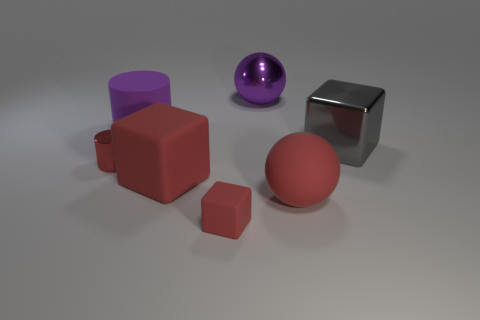Are there an equal number of metallic blocks that are behind the purple sphere and large metal blocks behind the big purple cylinder?
Your answer should be very brief. Yes. Are there any other things that have the same size as the rubber sphere?
Ensure brevity in your answer.  Yes. There is a big red thing that is the same shape as the small red matte object; what material is it?
Ensure brevity in your answer.  Rubber. Is there a big gray shiny thing left of the big matte thing to the right of the sphere that is behind the gray cube?
Your answer should be very brief. No. Does the large metallic thing that is behind the large gray metal thing have the same shape as the large matte thing that is behind the small cylinder?
Give a very brief answer. No. Is the number of red metallic cylinders left of the large rubber cylinder greater than the number of small red rubber objects?
Give a very brief answer. No. What number of things are big cubes or tiny blue spheres?
Your answer should be very brief. 2. What color is the rubber cylinder?
Make the answer very short. Purple. How many other things are there of the same color as the metallic cylinder?
Offer a terse response. 3. There is a shiny sphere; are there any large metal blocks on the right side of it?
Provide a succinct answer. Yes. 